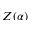<formula> <loc_0><loc_0><loc_500><loc_500>Z ( \alpha )</formula> 